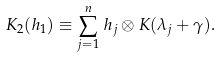<formula> <loc_0><loc_0><loc_500><loc_500>K _ { 2 } ( h _ { 1 } ) \equiv \sum _ { j = 1 } ^ { n } \, h _ { j } \otimes K ( \lambda _ { j } + \gamma ) .</formula> 